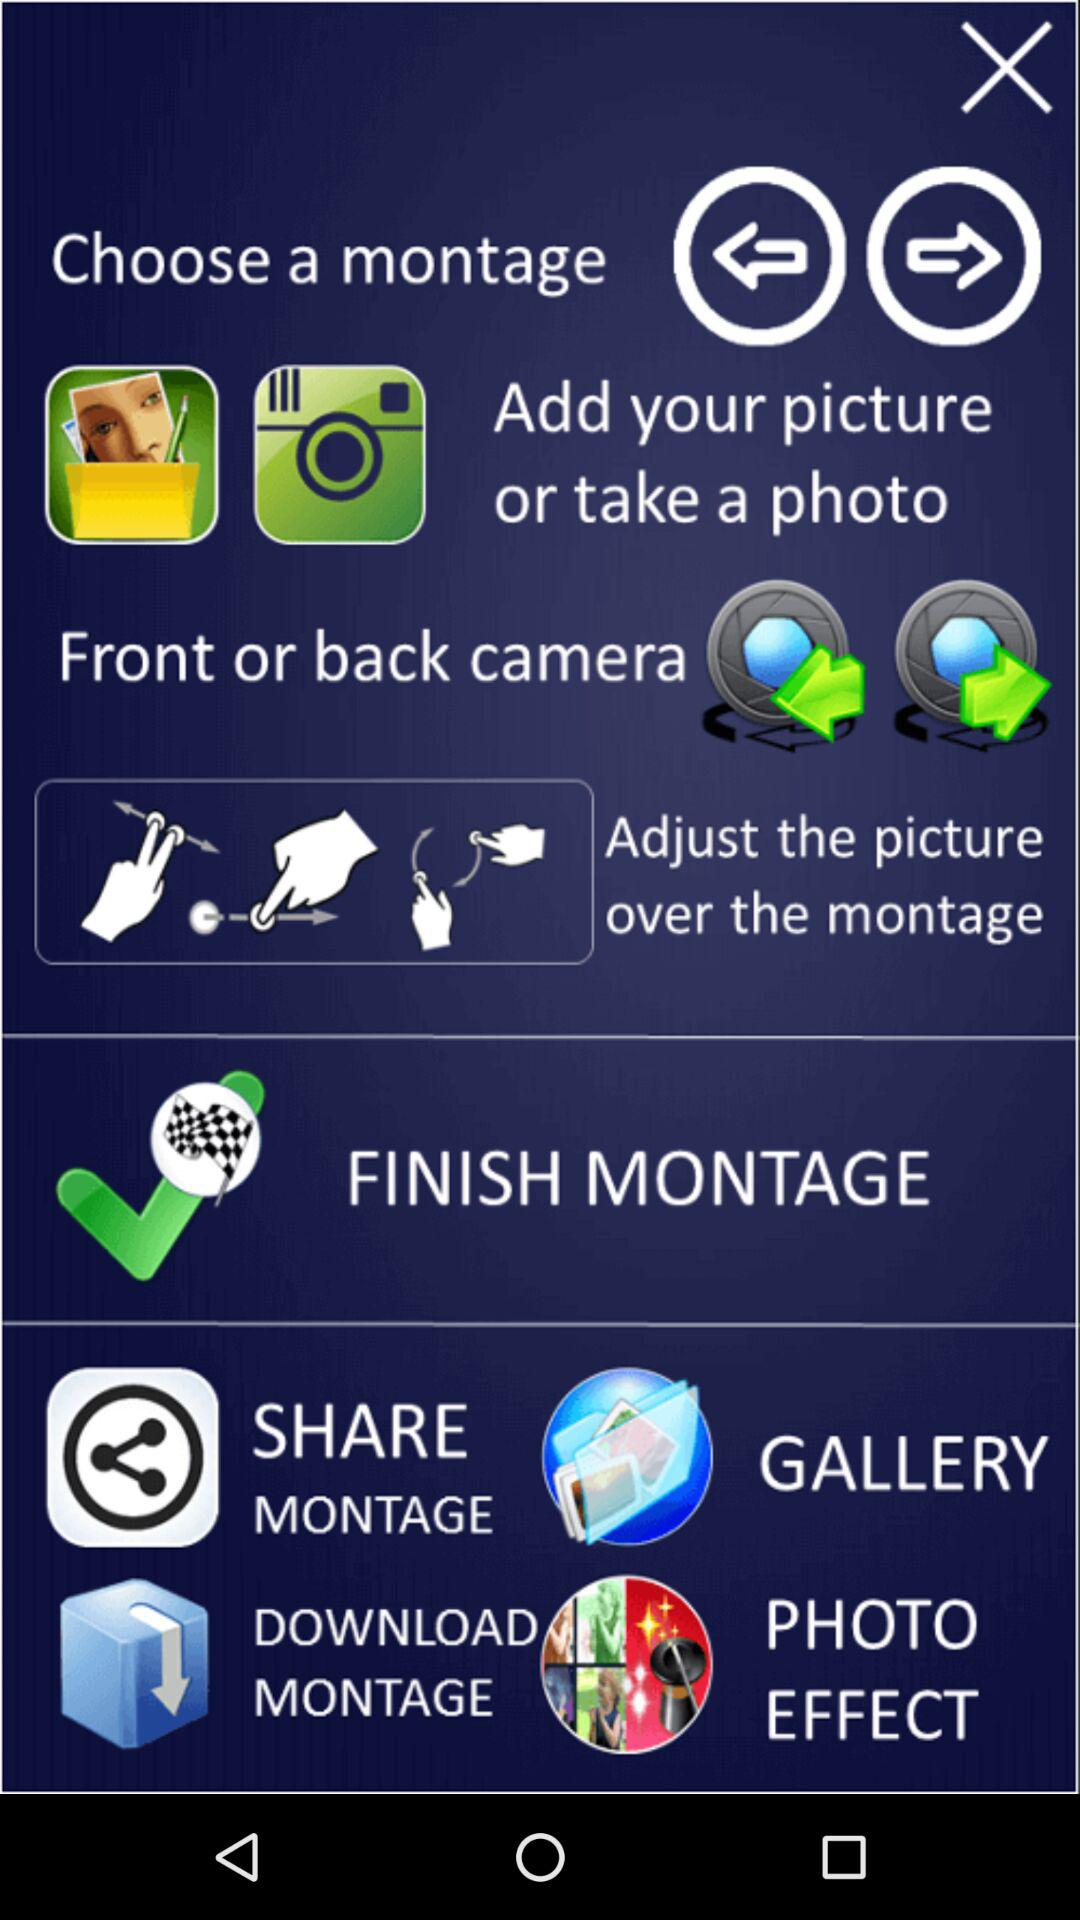What are the instructions to create a montage? The instructions are to add your picture or take a photo with your front or back camera and adjust the picture over the montage. 